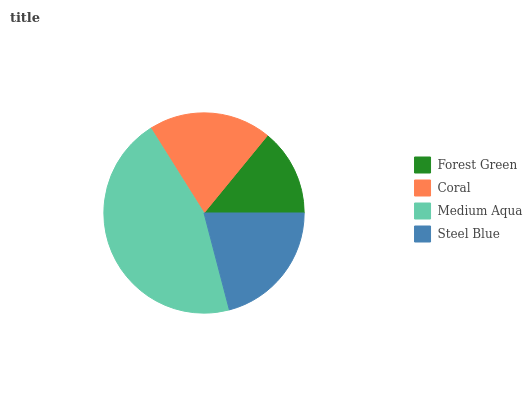Is Forest Green the minimum?
Answer yes or no. Yes. Is Medium Aqua the maximum?
Answer yes or no. Yes. Is Coral the minimum?
Answer yes or no. No. Is Coral the maximum?
Answer yes or no. No. Is Coral greater than Forest Green?
Answer yes or no. Yes. Is Forest Green less than Coral?
Answer yes or no. Yes. Is Forest Green greater than Coral?
Answer yes or no. No. Is Coral less than Forest Green?
Answer yes or no. No. Is Steel Blue the high median?
Answer yes or no. Yes. Is Coral the low median?
Answer yes or no. Yes. Is Forest Green the high median?
Answer yes or no. No. Is Steel Blue the low median?
Answer yes or no. No. 